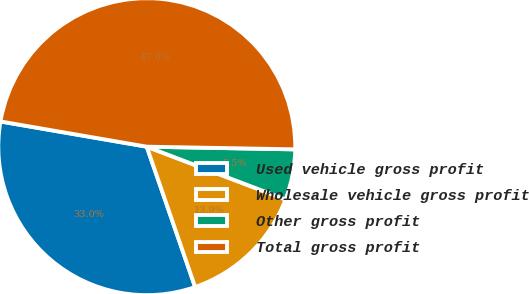<chart> <loc_0><loc_0><loc_500><loc_500><pie_chart><fcel>Used vehicle gross profit<fcel>Wholesale vehicle gross profit<fcel>Other gross profit<fcel>Total gross profit<nl><fcel>33.0%<fcel>13.93%<fcel>5.5%<fcel>47.57%<nl></chart> 